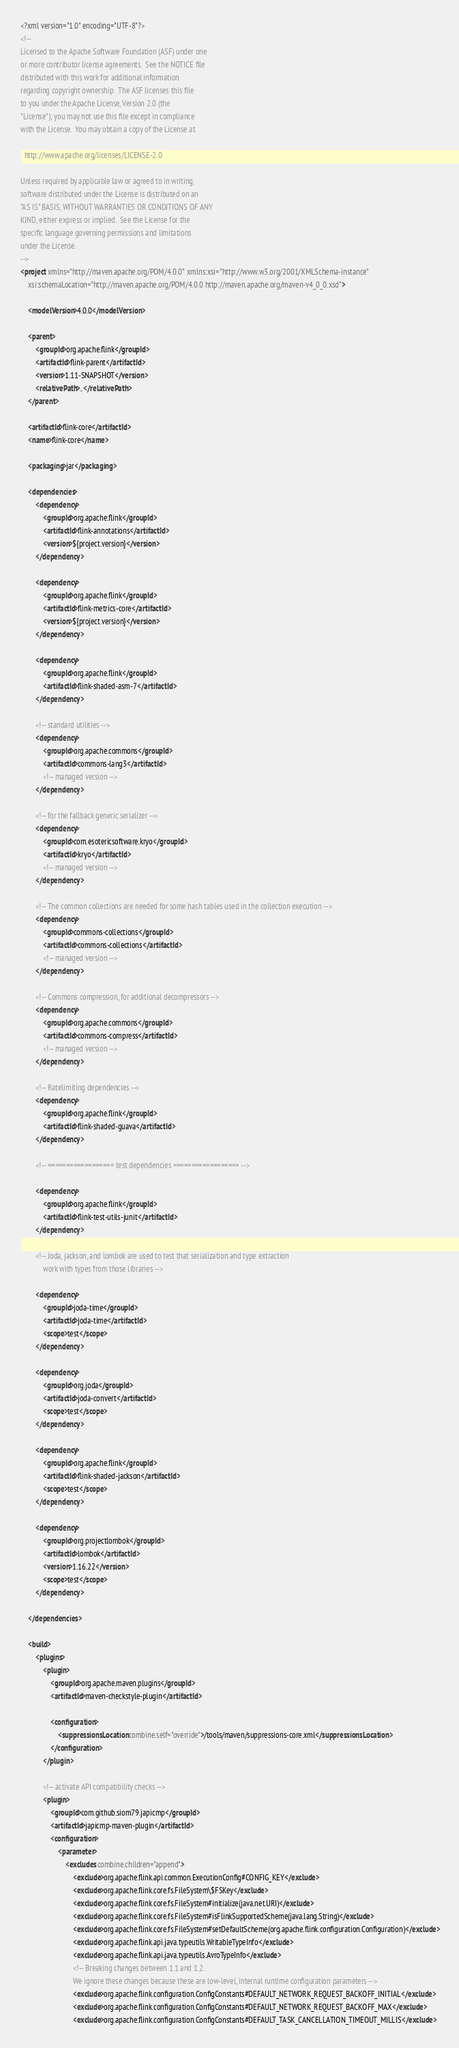<code> <loc_0><loc_0><loc_500><loc_500><_XML_><?xml version="1.0" encoding="UTF-8"?>
<!--
Licensed to the Apache Software Foundation (ASF) under one
or more contributor license agreements.  See the NOTICE file
distributed with this work for additional information
regarding copyright ownership.  The ASF licenses this file
to you under the Apache License, Version 2.0 (the
"License"); you may not use this file except in compliance
with the License.  You may obtain a copy of the License at

  http://www.apache.org/licenses/LICENSE-2.0

Unless required by applicable law or agreed to in writing,
software distributed under the License is distributed on an
"AS IS" BASIS, WITHOUT WARRANTIES OR CONDITIONS OF ANY
KIND, either express or implied.  See the License for the
specific language governing permissions and limitations
under the License.
-->
<project xmlns="http://maven.apache.org/POM/4.0.0" xmlns:xsi="http://www.w3.org/2001/XMLSchema-instance"
	xsi:schemaLocation="http://maven.apache.org/POM/4.0.0 http://maven.apache.org/maven-v4_0_0.xsd">

	<modelVersion>4.0.0</modelVersion>

	<parent>
		<groupId>org.apache.flink</groupId>
		<artifactId>flink-parent</artifactId>
		<version>1.11-SNAPSHOT</version>
		<relativePath>..</relativePath>
	</parent>

	<artifactId>flink-core</artifactId>
	<name>flink-core</name>

	<packaging>jar</packaging>

	<dependencies>
		<dependency>
			<groupId>org.apache.flink</groupId>
			<artifactId>flink-annotations</artifactId>
			<version>${project.version}</version>
		</dependency>

		<dependency>
			<groupId>org.apache.flink</groupId>
			<artifactId>flink-metrics-core</artifactId>
			<version>${project.version}</version>
		</dependency>

		<dependency>
			<groupId>org.apache.flink</groupId>
			<artifactId>flink-shaded-asm-7</artifactId>
		</dependency>

		<!-- standard utilities -->
		<dependency>
			<groupId>org.apache.commons</groupId>
			<artifactId>commons-lang3</artifactId>
			<!-- managed version -->
		</dependency>

		<!-- for the fallback generic serializer -->
		<dependency>
			<groupId>com.esotericsoftware.kryo</groupId>
			<artifactId>kryo</artifactId>
			<!-- managed version -->
		</dependency>

		<!-- The common collections are needed for some hash tables used in the collection execution -->
		<dependency>
			<groupId>commons-collections</groupId>
			<artifactId>commons-collections</artifactId>
			<!-- managed version -->
		</dependency>

		<!-- Commons compression, for additional decompressors -->
		<dependency>
			<groupId>org.apache.commons</groupId>
			<artifactId>commons-compress</artifactId>
			<!-- managed version -->
		</dependency>

		<!-- Ratelimiting dependencies -->
		<dependency>
			<groupId>org.apache.flink</groupId>
			<artifactId>flink-shaded-guava</artifactId>
		</dependency>

		<!-- ================== test dependencies ================== -->

		<dependency>
			<groupId>org.apache.flink</groupId>
			<artifactId>flink-test-utils-junit</artifactId>
		</dependency>

		<!-- Joda, jackson, and lombok are used to test that serialization and type extraction
			work with types from those libraries -->

		<dependency>
			<groupId>joda-time</groupId>
			<artifactId>joda-time</artifactId>
			<scope>test</scope>
		</dependency>

		<dependency>
			<groupId>org.joda</groupId>
			<artifactId>joda-convert</artifactId>
			<scope>test</scope>
		</dependency>

		<dependency>
			<groupId>org.apache.flink</groupId>
			<artifactId>flink-shaded-jackson</artifactId>
			<scope>test</scope>
		</dependency>

		<dependency>
			<groupId>org.projectlombok</groupId>
			<artifactId>lombok</artifactId>
			<version>1.16.22</version>
			<scope>test</scope>
		</dependency>

	</dependencies>

	<build>
		<plugins>
			<plugin>
				<groupId>org.apache.maven.plugins</groupId>
				<artifactId>maven-checkstyle-plugin</artifactId>

				<configuration>
					<suppressionsLocation combine.self="override">/tools/maven/suppressions-core.xml</suppressionsLocation>
				</configuration>
			</plugin>

			<!-- activate API compatibility checks -->
			<plugin>
				<groupId>com.github.siom79.japicmp</groupId>
				<artifactId>japicmp-maven-plugin</artifactId>
				<configuration>
					<parameter>
						<excludes combine.children="append">
							<exclude>org.apache.flink.api.common.ExecutionConfig#CONFIG_KEY</exclude>
							<exclude>org.apache.flink.core.fs.FileSystem\$FSKey</exclude>
							<exclude>org.apache.flink.core.fs.FileSystem#initialize(java.net.URI)</exclude>
							<exclude>org.apache.flink.core.fs.FileSystem#isFlinkSupportedScheme(java.lang.String)</exclude>
							<exclude>org.apache.flink.core.fs.FileSystem#setDefaultScheme(org.apache.flink.configuration.Configuration)</exclude>
							<exclude>org.apache.flink.api.java.typeutils.WritableTypeInfo</exclude>
							<exclude>org.apache.flink.api.java.typeutils.AvroTypeInfo</exclude>
							<!-- Breaking changes between 1.1 and 1.2.
							We ignore these changes because these are low-level, internal runtime configuration parameters -->
							<exclude>org.apache.flink.configuration.ConfigConstants#DEFAULT_NETWORK_REQUEST_BACKOFF_INITIAL</exclude>
							<exclude>org.apache.flink.configuration.ConfigConstants#DEFAULT_NETWORK_REQUEST_BACKOFF_MAX</exclude>
							<exclude>org.apache.flink.configuration.ConfigConstants#DEFAULT_TASK_CANCELLATION_TIMEOUT_MILLIS</exclude></code> 